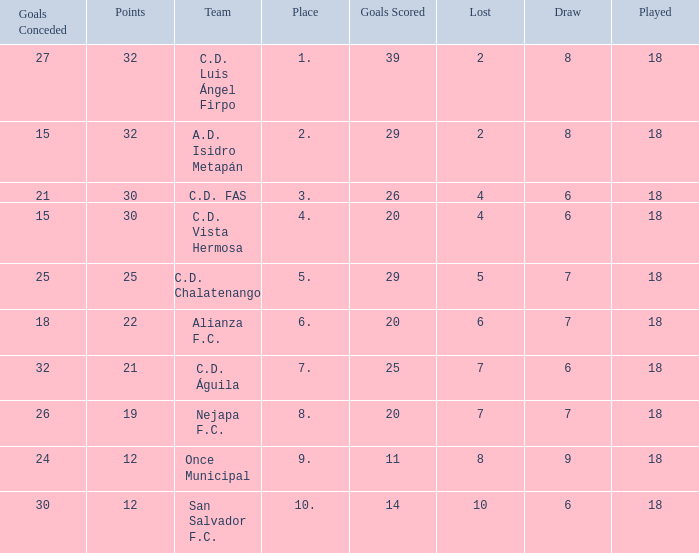What team with a goals conceded smaller than 25, and a place smaller than 3? A.D. Isidro Metapán. 